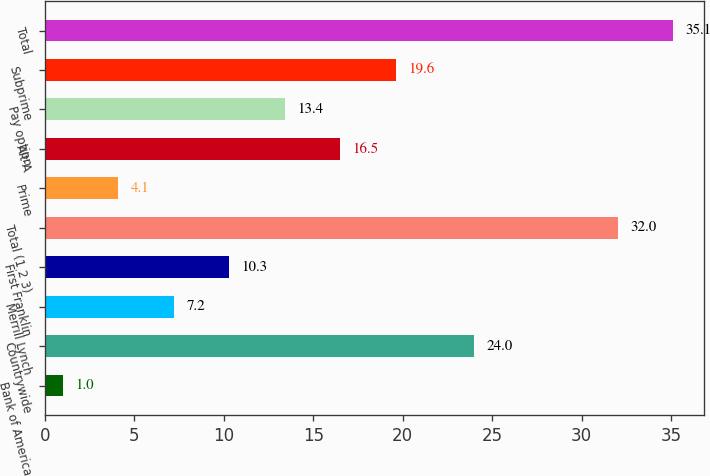<chart> <loc_0><loc_0><loc_500><loc_500><bar_chart><fcel>Bank of America<fcel>Countrywide<fcel>Merrill Lynch<fcel>First Franklin<fcel>Total (1 2 3)<fcel>Prime<fcel>Alt-A<fcel>Pay option<fcel>Subprime<fcel>Total<nl><fcel>1<fcel>24<fcel>7.2<fcel>10.3<fcel>32<fcel>4.1<fcel>16.5<fcel>13.4<fcel>19.6<fcel>35.1<nl></chart> 